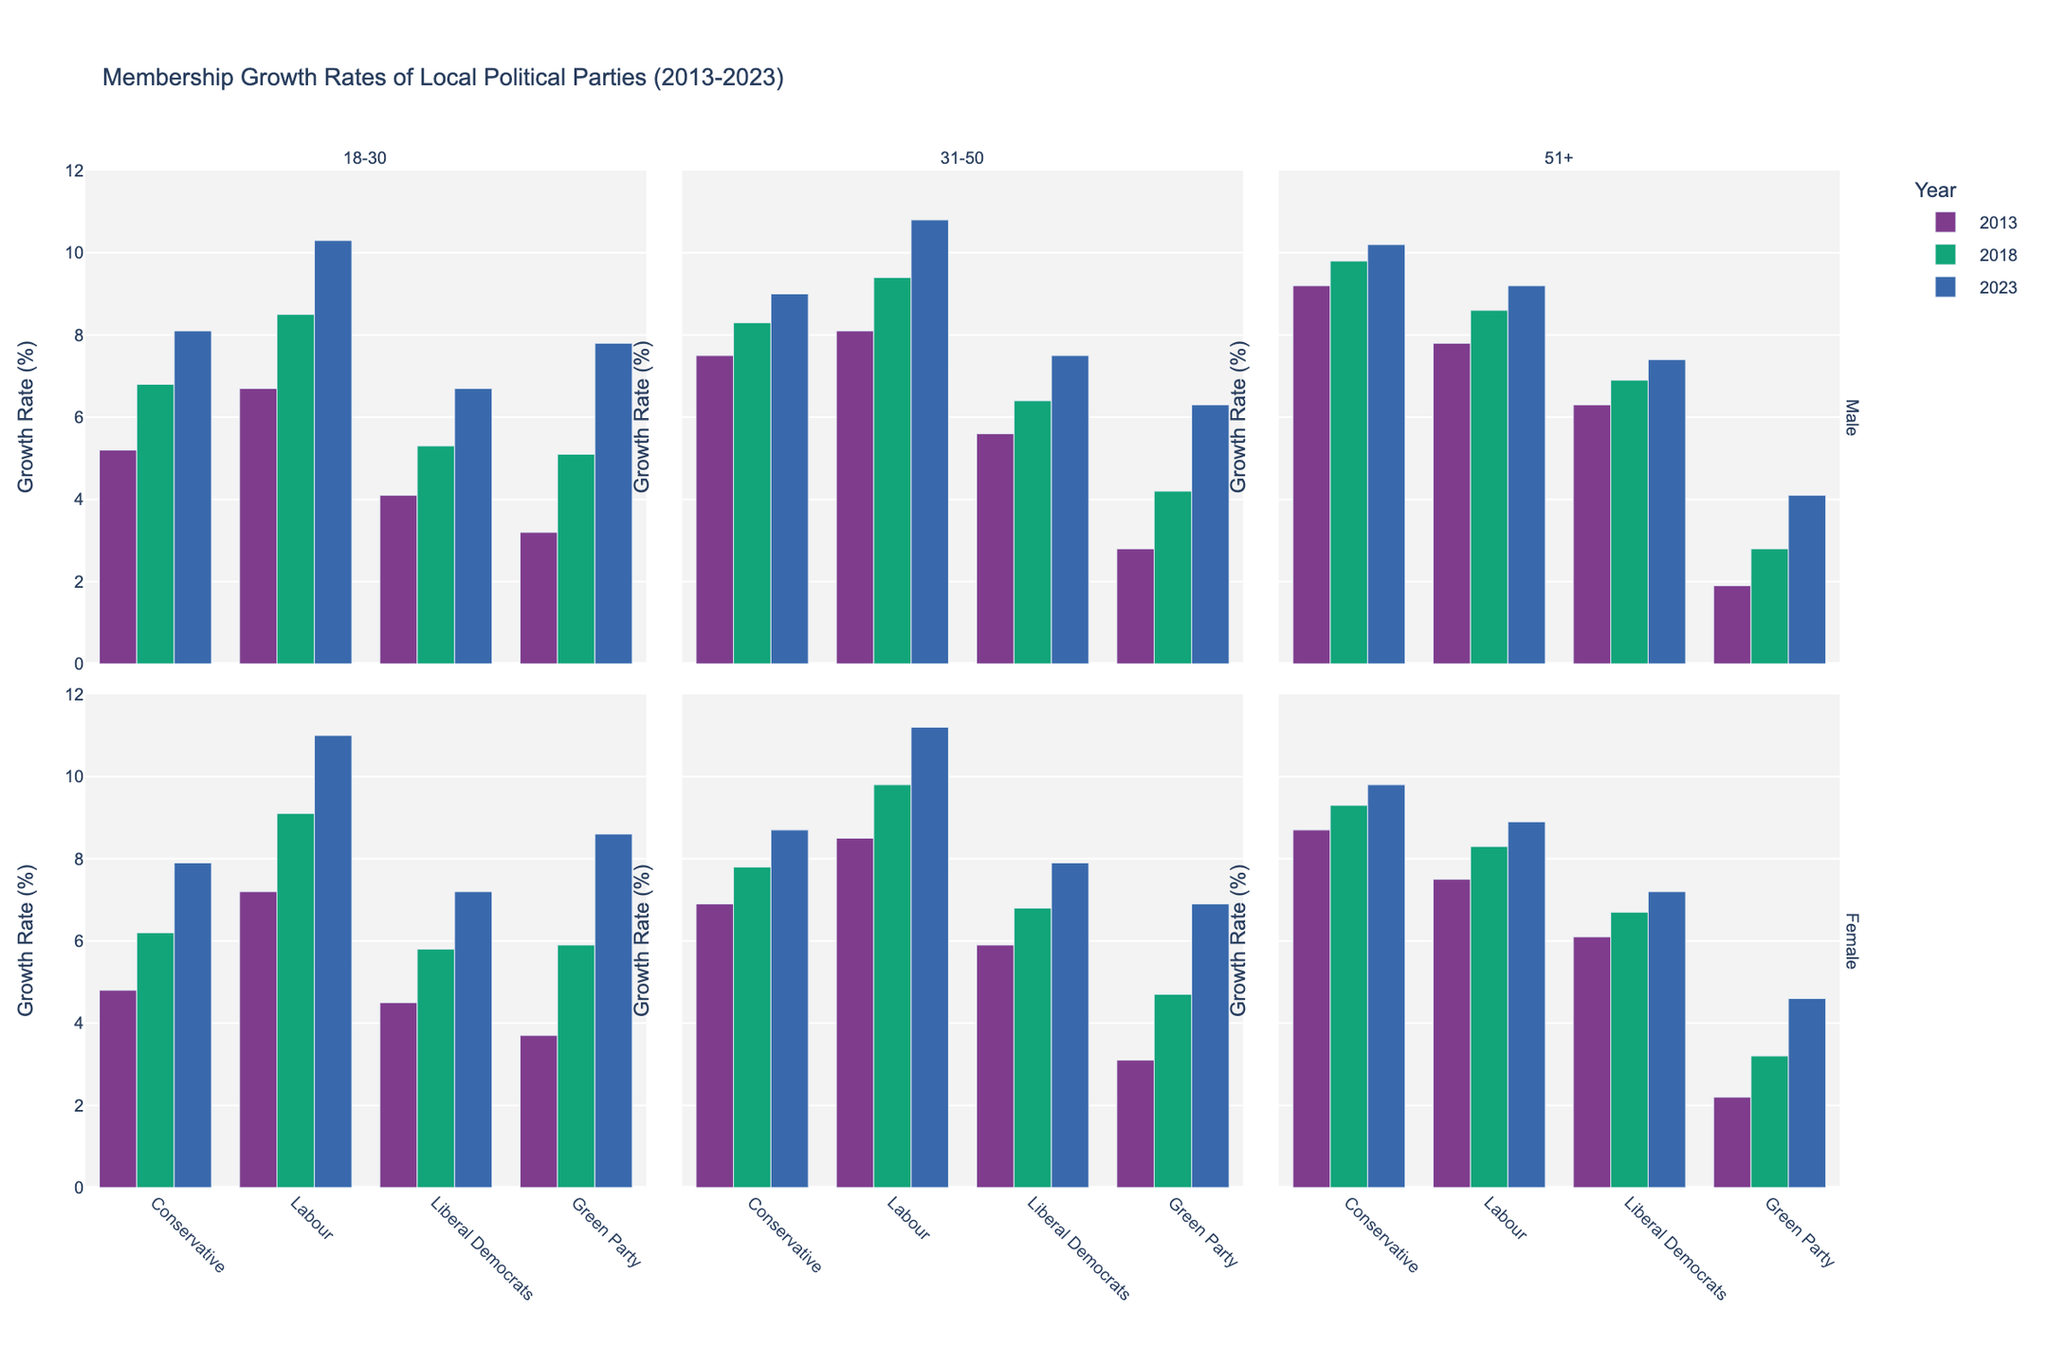Which party showed the highest membership growth rate for females aged 18-30 in 2023? By looking at the height of the bars in the section where Gender is Female and Age Group is 18-30 in the 2023 data, the Labour party has the highest membership growth rate.
Answer: Labour How did the membership growth rate for Labour males aged 31-50 change from 2013 to 2023? To find this, observe the height of the bars corresponding to the Labour party, Gender male, and Age Group 31-50. In 2013, the rate was 8.1%, and in 2023, it was 10.8%. The difference is 10.8% - 8.1% = 2.7%.
Answer: Increased by 2.7% What is the average membership growth rate for Conservative females across all age groups in 2018? Sum the Conservative female membership growth rates in 2018 (6.2% for 18-30, 7.8% for 31-50, and 9.3% for 51+), then divide by the number of age groups: (6.2 + 7.8 + 9.3) / 3 = 7.8%.
Answer: 7.8% Which party had the smallest membership growth rate for males aged 51+ in 2013, and what was it? Look at the bars under the Male 51+ section for 2013. The Green Party has the smallest rate at 1.9%.
Answer: Green Party with 1.9% Which gender and age group had a larger membership growth rate in the Liberal Democrats party in 2023: males aged 31-50 or females aged 18-30? Compare the heights of the bars for these categories. Males aged 31-50 (7.5%) and females aged 18-30 (7.2%). Since 7.5% > 7.2%, males aged 31-50 had a larger growth rate.
Answer: Males aged 31-50 By how much did the membership growth rate for Conservative males aged 51+ increase from 2013 to 2023? The rate in 2013 was 9.2% and in 2023 it was 10.2%. The increase is 10.2% - 9.2% = 1.0%.
Answer: 1.0% Which party had a higher membership growth rate for females aged 31-50 in 2023: Labour or Conservative? Compare the heights of the bars for Labour (11.2%) and Conservative (8.7%) females aged 31-50 in 2023. Labour has a higher rate.
Answer: Labour What is the sum of membership growth rates for Green Party males across all age groups in 2023? Add the rates for Green Party males in 2023: 7.8% (18-30) + 6.3% (31-50) + 4.1% (51+). The sum is 7.8 + 6.3 + 4.1 = 18.2%.
Answer: 18.2% How does the membership growth rate of Labour females aged 18-30 in 2023 compare to that of Green Party males aged 18-30 in the same year? The growth rate for Labour females aged 18-30 is 11.0%, and for Green Party males aged 18-30, it is 7.8%. Since 11.0% > 7.8%, Labour females aged 18-30 had a higher growth rate.
Answer: Labour females aged 18-30 had a higher growth rate 